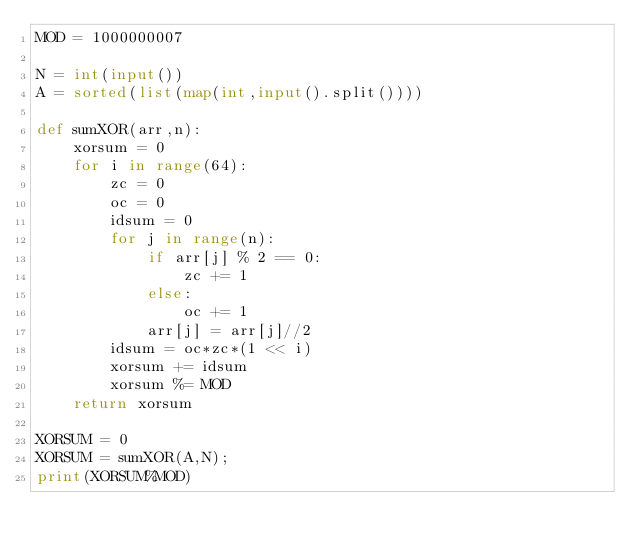Convert code to text. <code><loc_0><loc_0><loc_500><loc_500><_Python_>MOD = 1000000007

N = int(input())
A = sorted(list(map(int,input().split())))

def sumXOR(arr,n):
    xorsum = 0
    for i in range(64):
        zc = 0
        oc = 0
        idsum = 0
        for j in range(n):
            if arr[j] % 2 == 0:
                zc += 1
            else:
                oc += 1
            arr[j] = arr[j]//2
        idsum = oc*zc*(1 << i)
        xorsum += idsum
        xorsum %= MOD
    return xorsum

XORSUM = 0
XORSUM = sumXOR(A,N);
print(XORSUM%MOD)</code> 